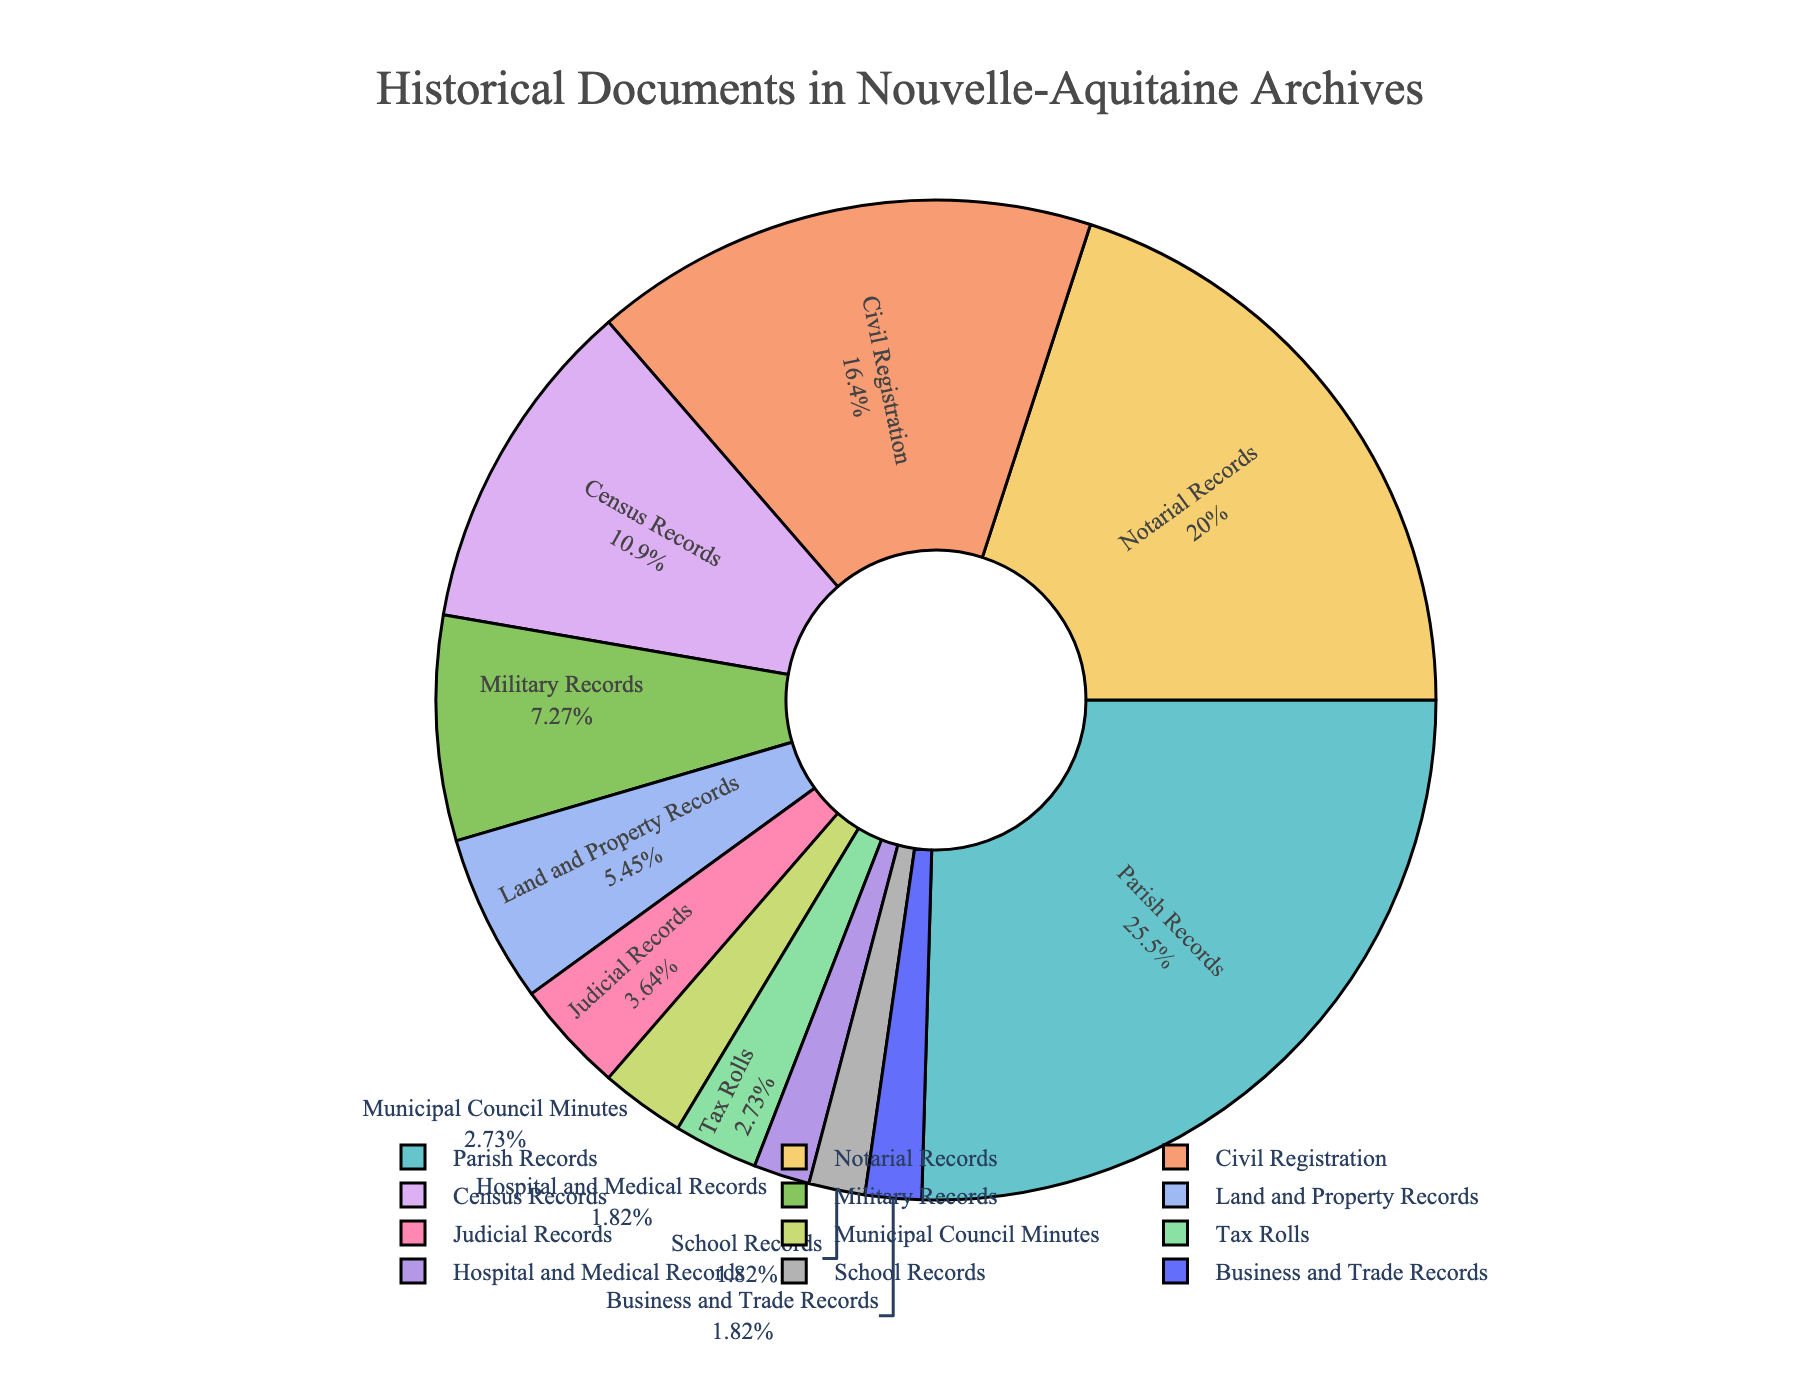what type of historical document constitutes the largest portion of the archives? The figure shows that Parish Records make up the largest portion with the highest percentage.
Answer: Parish Records What is the combined percentage of Notarial Records and Civil Registration in the archives? Add the percentages of Notarial Records and Civil Registration: 22% + 18% = 40%.
Answer: 40% Which types of historical records both make up 2% of the archives? The figure shows that Hospital and Medical Records, School Records, and Business and Trade Records each make up 2% of the archives.
Answer: Hospital and Medical Records, School Records, Business and Trade Records How does the percentage of Military Records compare to that of Census Records? The percentage of Military Records (8%) is less than that of Census Records (12%).
Answer: Military Records are less If you combine the percentages for Judicial Records, Municipal Council Minutes, and Tax Rolls, does it exceed the percentage of Civil Registration Records? Add the percentages of Judicial Records, Municipal Council Minutes, and Tax Rolls: 4% + 3% + 3% = 10%. The percentage of Civil Registration Records is 18%. Thus, the combined percentage does not exceed the percentage of Civil Registration Records.
Answer: No In terms of visual attributes, which segment appears to be the smallest? The segment for Hospital and Medical Records, School Records, and Business and Trade Records all make up 2%, appearing visually smaller compared to others.
Answer: Hospital and Medical Records, School Records, Business and Trade Records How much greater is the percentage of Parish Records compared to that of Land and Property Records? Subtract the percentage of Land and Property Records from that of Parish Records: 28% - 6% = 22%.
Answer: 22% What proportion of historical documents is made up by types of records present in single-digit percentages? Add the percentages of Military Records (8%), Land and Property Records (6%), Judicial Records (4%), Municipal Council Minutes (3%), Tax Rolls (3%), Hospital and Medical Records (2%), School Records (2%), and Business and Trade Records (2%): 8% + 6% + 4% + 3% + 3% + 2% + 2% + 2% = 30%.
Answer: 30% 